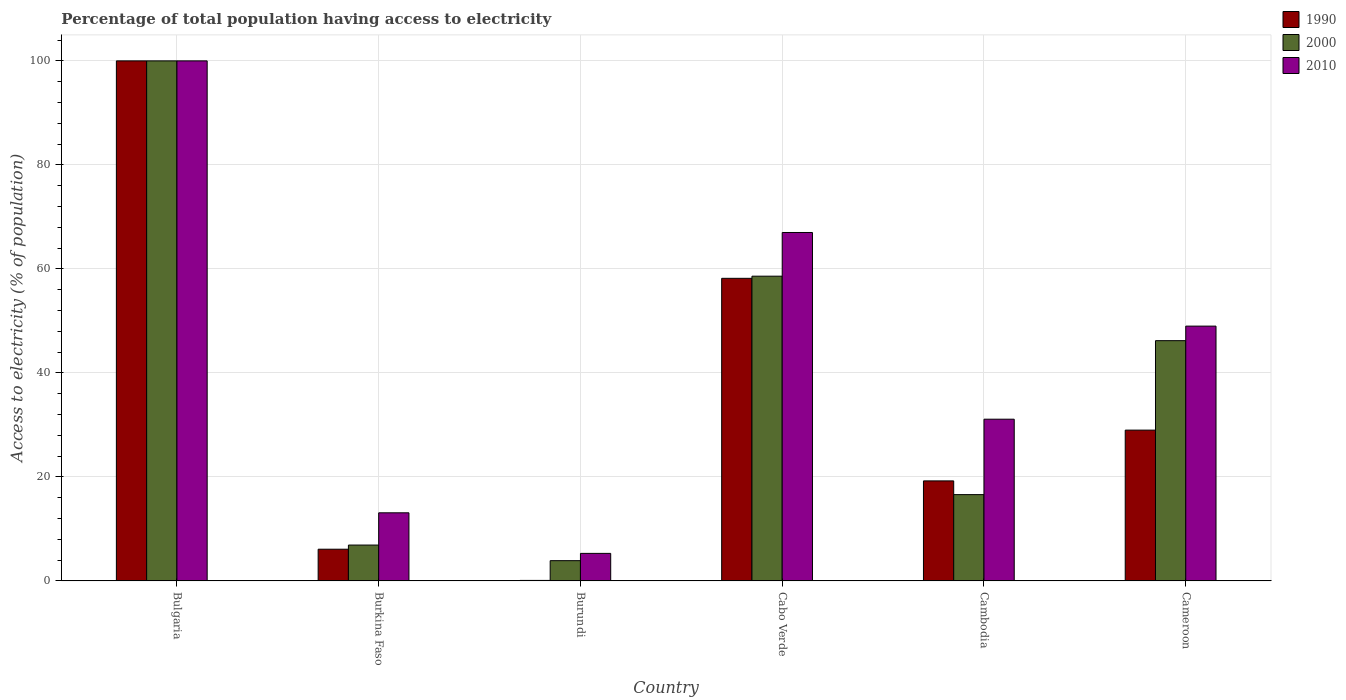How many groups of bars are there?
Offer a very short reply. 6. Are the number of bars on each tick of the X-axis equal?
Your response must be concise. Yes. What is the label of the 6th group of bars from the left?
Your answer should be compact. Cameroon. In which country was the percentage of population that have access to electricity in 2010 minimum?
Keep it short and to the point. Burundi. What is the total percentage of population that have access to electricity in 1990 in the graph?
Your answer should be very brief. 212.63. What is the difference between the percentage of population that have access to electricity in 1990 in Burundi and that in Cambodia?
Keep it short and to the point. -19.14. What is the difference between the percentage of population that have access to electricity in 2010 in Bulgaria and the percentage of population that have access to electricity in 2000 in Burkina Faso?
Ensure brevity in your answer.  93.1. What is the average percentage of population that have access to electricity in 1990 per country?
Provide a succinct answer. 35.44. In how many countries, is the percentage of population that have access to electricity in 1990 greater than 28 %?
Keep it short and to the point. 3. What is the ratio of the percentage of population that have access to electricity in 1990 in Burkina Faso to that in Burundi?
Ensure brevity in your answer.  61. What is the difference between the highest and the second highest percentage of population that have access to electricity in 2000?
Ensure brevity in your answer.  -41.4. What is the difference between the highest and the lowest percentage of population that have access to electricity in 2010?
Your answer should be very brief. 94.7. In how many countries, is the percentage of population that have access to electricity in 2010 greater than the average percentage of population that have access to electricity in 2010 taken over all countries?
Your answer should be very brief. 3. What does the 3rd bar from the left in Cameroon represents?
Make the answer very short. 2010. What does the 3rd bar from the right in Cambodia represents?
Your response must be concise. 1990. Is it the case that in every country, the sum of the percentage of population that have access to electricity in 1990 and percentage of population that have access to electricity in 2010 is greater than the percentage of population that have access to electricity in 2000?
Ensure brevity in your answer.  Yes. What is the difference between two consecutive major ticks on the Y-axis?
Make the answer very short. 20. Are the values on the major ticks of Y-axis written in scientific E-notation?
Provide a succinct answer. No. Does the graph contain grids?
Your response must be concise. Yes. Where does the legend appear in the graph?
Make the answer very short. Top right. How many legend labels are there?
Provide a short and direct response. 3. How are the legend labels stacked?
Ensure brevity in your answer.  Vertical. What is the title of the graph?
Your answer should be compact. Percentage of total population having access to electricity. Does "1962" appear as one of the legend labels in the graph?
Provide a short and direct response. No. What is the label or title of the Y-axis?
Your answer should be compact. Access to electricity (% of population). What is the Access to electricity (% of population) of 1990 in Bulgaria?
Ensure brevity in your answer.  100. What is the Access to electricity (% of population) of 2000 in Burkina Faso?
Provide a succinct answer. 6.9. What is the Access to electricity (% of population) of 2010 in Burkina Faso?
Provide a short and direct response. 13.1. What is the Access to electricity (% of population) of 1990 in Burundi?
Your response must be concise. 0.1. What is the Access to electricity (% of population) in 2000 in Burundi?
Your answer should be very brief. 3.9. What is the Access to electricity (% of population) in 1990 in Cabo Verde?
Offer a terse response. 58.19. What is the Access to electricity (% of population) in 2000 in Cabo Verde?
Offer a very short reply. 58.6. What is the Access to electricity (% of population) in 1990 in Cambodia?
Your answer should be very brief. 19.24. What is the Access to electricity (% of population) of 2000 in Cambodia?
Keep it short and to the point. 16.6. What is the Access to electricity (% of population) of 2010 in Cambodia?
Offer a terse response. 31.1. What is the Access to electricity (% of population) of 1990 in Cameroon?
Provide a succinct answer. 29. What is the Access to electricity (% of population) in 2000 in Cameroon?
Give a very brief answer. 46.2. What is the Access to electricity (% of population) in 2010 in Cameroon?
Keep it short and to the point. 49. Across all countries, what is the minimum Access to electricity (% of population) in 1990?
Your answer should be compact. 0.1. Across all countries, what is the minimum Access to electricity (% of population) in 2000?
Your answer should be very brief. 3.9. What is the total Access to electricity (% of population) of 1990 in the graph?
Ensure brevity in your answer.  212.63. What is the total Access to electricity (% of population) in 2000 in the graph?
Your answer should be compact. 232.2. What is the total Access to electricity (% of population) in 2010 in the graph?
Provide a short and direct response. 265.5. What is the difference between the Access to electricity (% of population) of 1990 in Bulgaria and that in Burkina Faso?
Offer a terse response. 93.9. What is the difference between the Access to electricity (% of population) of 2000 in Bulgaria and that in Burkina Faso?
Offer a very short reply. 93.1. What is the difference between the Access to electricity (% of population) in 2010 in Bulgaria and that in Burkina Faso?
Your answer should be compact. 86.9. What is the difference between the Access to electricity (% of population) of 1990 in Bulgaria and that in Burundi?
Offer a very short reply. 99.9. What is the difference between the Access to electricity (% of population) in 2000 in Bulgaria and that in Burundi?
Ensure brevity in your answer.  96.1. What is the difference between the Access to electricity (% of population) in 2010 in Bulgaria and that in Burundi?
Your answer should be compact. 94.7. What is the difference between the Access to electricity (% of population) in 1990 in Bulgaria and that in Cabo Verde?
Ensure brevity in your answer.  41.81. What is the difference between the Access to electricity (% of population) of 2000 in Bulgaria and that in Cabo Verde?
Your answer should be very brief. 41.4. What is the difference between the Access to electricity (% of population) in 1990 in Bulgaria and that in Cambodia?
Give a very brief answer. 80.76. What is the difference between the Access to electricity (% of population) in 2000 in Bulgaria and that in Cambodia?
Provide a short and direct response. 83.4. What is the difference between the Access to electricity (% of population) of 2010 in Bulgaria and that in Cambodia?
Your answer should be very brief. 68.9. What is the difference between the Access to electricity (% of population) of 2000 in Bulgaria and that in Cameroon?
Make the answer very short. 53.8. What is the difference between the Access to electricity (% of population) of 1990 in Burkina Faso and that in Burundi?
Your answer should be compact. 6. What is the difference between the Access to electricity (% of population) of 2000 in Burkina Faso and that in Burundi?
Offer a very short reply. 3. What is the difference between the Access to electricity (% of population) of 2010 in Burkina Faso and that in Burundi?
Your response must be concise. 7.8. What is the difference between the Access to electricity (% of population) of 1990 in Burkina Faso and that in Cabo Verde?
Your response must be concise. -52.09. What is the difference between the Access to electricity (% of population) in 2000 in Burkina Faso and that in Cabo Verde?
Your answer should be very brief. -51.7. What is the difference between the Access to electricity (% of population) in 2010 in Burkina Faso and that in Cabo Verde?
Offer a very short reply. -53.9. What is the difference between the Access to electricity (% of population) in 1990 in Burkina Faso and that in Cambodia?
Make the answer very short. -13.14. What is the difference between the Access to electricity (% of population) of 2010 in Burkina Faso and that in Cambodia?
Ensure brevity in your answer.  -18. What is the difference between the Access to electricity (% of population) of 1990 in Burkina Faso and that in Cameroon?
Provide a short and direct response. -22.9. What is the difference between the Access to electricity (% of population) of 2000 in Burkina Faso and that in Cameroon?
Offer a terse response. -39.3. What is the difference between the Access to electricity (% of population) of 2010 in Burkina Faso and that in Cameroon?
Provide a succinct answer. -35.9. What is the difference between the Access to electricity (% of population) in 1990 in Burundi and that in Cabo Verde?
Your answer should be very brief. -58.09. What is the difference between the Access to electricity (% of population) in 2000 in Burundi and that in Cabo Verde?
Give a very brief answer. -54.7. What is the difference between the Access to electricity (% of population) in 2010 in Burundi and that in Cabo Verde?
Offer a very short reply. -61.7. What is the difference between the Access to electricity (% of population) in 1990 in Burundi and that in Cambodia?
Your answer should be compact. -19.14. What is the difference between the Access to electricity (% of population) in 2000 in Burundi and that in Cambodia?
Provide a short and direct response. -12.7. What is the difference between the Access to electricity (% of population) of 2010 in Burundi and that in Cambodia?
Provide a succinct answer. -25.8. What is the difference between the Access to electricity (% of population) in 1990 in Burundi and that in Cameroon?
Your answer should be compact. -28.9. What is the difference between the Access to electricity (% of population) in 2000 in Burundi and that in Cameroon?
Provide a succinct answer. -42.3. What is the difference between the Access to electricity (% of population) in 2010 in Burundi and that in Cameroon?
Your answer should be compact. -43.7. What is the difference between the Access to electricity (% of population) of 1990 in Cabo Verde and that in Cambodia?
Offer a terse response. 38.95. What is the difference between the Access to electricity (% of population) of 2000 in Cabo Verde and that in Cambodia?
Give a very brief answer. 42. What is the difference between the Access to electricity (% of population) in 2010 in Cabo Verde and that in Cambodia?
Make the answer very short. 35.9. What is the difference between the Access to electricity (% of population) of 1990 in Cabo Verde and that in Cameroon?
Ensure brevity in your answer.  29.19. What is the difference between the Access to electricity (% of population) of 1990 in Cambodia and that in Cameroon?
Keep it short and to the point. -9.76. What is the difference between the Access to electricity (% of population) of 2000 in Cambodia and that in Cameroon?
Make the answer very short. -29.6. What is the difference between the Access to electricity (% of population) of 2010 in Cambodia and that in Cameroon?
Keep it short and to the point. -17.9. What is the difference between the Access to electricity (% of population) in 1990 in Bulgaria and the Access to electricity (% of population) in 2000 in Burkina Faso?
Keep it short and to the point. 93.1. What is the difference between the Access to electricity (% of population) of 1990 in Bulgaria and the Access to electricity (% of population) of 2010 in Burkina Faso?
Provide a short and direct response. 86.9. What is the difference between the Access to electricity (% of population) in 2000 in Bulgaria and the Access to electricity (% of population) in 2010 in Burkina Faso?
Give a very brief answer. 86.9. What is the difference between the Access to electricity (% of population) of 1990 in Bulgaria and the Access to electricity (% of population) of 2000 in Burundi?
Your answer should be very brief. 96.1. What is the difference between the Access to electricity (% of population) in 1990 in Bulgaria and the Access to electricity (% of population) in 2010 in Burundi?
Your response must be concise. 94.7. What is the difference between the Access to electricity (% of population) in 2000 in Bulgaria and the Access to electricity (% of population) in 2010 in Burundi?
Offer a terse response. 94.7. What is the difference between the Access to electricity (% of population) of 1990 in Bulgaria and the Access to electricity (% of population) of 2000 in Cabo Verde?
Offer a very short reply. 41.4. What is the difference between the Access to electricity (% of population) in 1990 in Bulgaria and the Access to electricity (% of population) in 2000 in Cambodia?
Provide a short and direct response. 83.4. What is the difference between the Access to electricity (% of population) of 1990 in Bulgaria and the Access to electricity (% of population) of 2010 in Cambodia?
Offer a terse response. 68.9. What is the difference between the Access to electricity (% of population) of 2000 in Bulgaria and the Access to electricity (% of population) of 2010 in Cambodia?
Keep it short and to the point. 68.9. What is the difference between the Access to electricity (% of population) of 1990 in Bulgaria and the Access to electricity (% of population) of 2000 in Cameroon?
Keep it short and to the point. 53.8. What is the difference between the Access to electricity (% of population) in 1990 in Bulgaria and the Access to electricity (% of population) in 2010 in Cameroon?
Give a very brief answer. 51. What is the difference between the Access to electricity (% of population) of 1990 in Burkina Faso and the Access to electricity (% of population) of 2000 in Burundi?
Offer a terse response. 2.2. What is the difference between the Access to electricity (% of population) in 1990 in Burkina Faso and the Access to electricity (% of population) in 2000 in Cabo Verde?
Your response must be concise. -52.5. What is the difference between the Access to electricity (% of population) of 1990 in Burkina Faso and the Access to electricity (% of population) of 2010 in Cabo Verde?
Your answer should be very brief. -60.9. What is the difference between the Access to electricity (% of population) of 2000 in Burkina Faso and the Access to electricity (% of population) of 2010 in Cabo Verde?
Offer a terse response. -60.1. What is the difference between the Access to electricity (% of population) of 1990 in Burkina Faso and the Access to electricity (% of population) of 2000 in Cambodia?
Ensure brevity in your answer.  -10.5. What is the difference between the Access to electricity (% of population) in 1990 in Burkina Faso and the Access to electricity (% of population) in 2010 in Cambodia?
Keep it short and to the point. -25. What is the difference between the Access to electricity (% of population) in 2000 in Burkina Faso and the Access to electricity (% of population) in 2010 in Cambodia?
Keep it short and to the point. -24.2. What is the difference between the Access to electricity (% of population) in 1990 in Burkina Faso and the Access to electricity (% of population) in 2000 in Cameroon?
Offer a very short reply. -40.1. What is the difference between the Access to electricity (% of population) in 1990 in Burkina Faso and the Access to electricity (% of population) in 2010 in Cameroon?
Your answer should be very brief. -42.9. What is the difference between the Access to electricity (% of population) in 2000 in Burkina Faso and the Access to electricity (% of population) in 2010 in Cameroon?
Make the answer very short. -42.1. What is the difference between the Access to electricity (% of population) of 1990 in Burundi and the Access to electricity (% of population) of 2000 in Cabo Verde?
Your response must be concise. -58.5. What is the difference between the Access to electricity (% of population) of 1990 in Burundi and the Access to electricity (% of population) of 2010 in Cabo Verde?
Offer a very short reply. -66.9. What is the difference between the Access to electricity (% of population) of 2000 in Burundi and the Access to electricity (% of population) of 2010 in Cabo Verde?
Ensure brevity in your answer.  -63.1. What is the difference between the Access to electricity (% of population) in 1990 in Burundi and the Access to electricity (% of population) in 2000 in Cambodia?
Your response must be concise. -16.5. What is the difference between the Access to electricity (% of population) of 1990 in Burundi and the Access to electricity (% of population) of 2010 in Cambodia?
Offer a terse response. -31. What is the difference between the Access to electricity (% of population) of 2000 in Burundi and the Access to electricity (% of population) of 2010 in Cambodia?
Offer a very short reply. -27.2. What is the difference between the Access to electricity (% of population) in 1990 in Burundi and the Access to electricity (% of population) in 2000 in Cameroon?
Your answer should be compact. -46.1. What is the difference between the Access to electricity (% of population) in 1990 in Burundi and the Access to electricity (% of population) in 2010 in Cameroon?
Your answer should be compact. -48.9. What is the difference between the Access to electricity (% of population) of 2000 in Burundi and the Access to electricity (% of population) of 2010 in Cameroon?
Keep it short and to the point. -45.1. What is the difference between the Access to electricity (% of population) of 1990 in Cabo Verde and the Access to electricity (% of population) of 2000 in Cambodia?
Your answer should be very brief. 41.59. What is the difference between the Access to electricity (% of population) in 1990 in Cabo Verde and the Access to electricity (% of population) in 2010 in Cambodia?
Make the answer very short. 27.09. What is the difference between the Access to electricity (% of population) of 2000 in Cabo Verde and the Access to electricity (% of population) of 2010 in Cambodia?
Offer a very short reply. 27.5. What is the difference between the Access to electricity (% of population) in 1990 in Cabo Verde and the Access to electricity (% of population) in 2000 in Cameroon?
Your answer should be very brief. 11.99. What is the difference between the Access to electricity (% of population) of 1990 in Cabo Verde and the Access to electricity (% of population) of 2010 in Cameroon?
Your answer should be compact. 9.19. What is the difference between the Access to electricity (% of population) in 1990 in Cambodia and the Access to electricity (% of population) in 2000 in Cameroon?
Your answer should be very brief. -26.96. What is the difference between the Access to electricity (% of population) of 1990 in Cambodia and the Access to electricity (% of population) of 2010 in Cameroon?
Give a very brief answer. -29.76. What is the difference between the Access to electricity (% of population) in 2000 in Cambodia and the Access to electricity (% of population) in 2010 in Cameroon?
Make the answer very short. -32.4. What is the average Access to electricity (% of population) in 1990 per country?
Your answer should be compact. 35.44. What is the average Access to electricity (% of population) in 2000 per country?
Ensure brevity in your answer.  38.7. What is the average Access to electricity (% of population) in 2010 per country?
Your answer should be very brief. 44.25. What is the difference between the Access to electricity (% of population) in 1990 and Access to electricity (% of population) in 2010 in Bulgaria?
Provide a succinct answer. 0. What is the difference between the Access to electricity (% of population) of 1990 and Access to electricity (% of population) of 2000 in Burundi?
Your answer should be very brief. -3.8. What is the difference between the Access to electricity (% of population) in 1990 and Access to electricity (% of population) in 2010 in Burundi?
Your answer should be compact. -5.2. What is the difference between the Access to electricity (% of population) of 1990 and Access to electricity (% of population) of 2000 in Cabo Verde?
Offer a terse response. -0.41. What is the difference between the Access to electricity (% of population) in 1990 and Access to electricity (% of population) in 2010 in Cabo Verde?
Offer a terse response. -8.81. What is the difference between the Access to electricity (% of population) in 2000 and Access to electricity (% of population) in 2010 in Cabo Verde?
Ensure brevity in your answer.  -8.4. What is the difference between the Access to electricity (% of population) of 1990 and Access to electricity (% of population) of 2000 in Cambodia?
Offer a terse response. 2.64. What is the difference between the Access to electricity (% of population) of 1990 and Access to electricity (% of population) of 2010 in Cambodia?
Your response must be concise. -11.86. What is the difference between the Access to electricity (% of population) in 1990 and Access to electricity (% of population) in 2000 in Cameroon?
Offer a terse response. -17.2. What is the ratio of the Access to electricity (% of population) of 1990 in Bulgaria to that in Burkina Faso?
Provide a short and direct response. 16.39. What is the ratio of the Access to electricity (% of population) of 2000 in Bulgaria to that in Burkina Faso?
Keep it short and to the point. 14.49. What is the ratio of the Access to electricity (% of population) of 2010 in Bulgaria to that in Burkina Faso?
Ensure brevity in your answer.  7.63. What is the ratio of the Access to electricity (% of population) of 2000 in Bulgaria to that in Burundi?
Offer a terse response. 25.64. What is the ratio of the Access to electricity (% of population) of 2010 in Bulgaria to that in Burundi?
Your answer should be very brief. 18.87. What is the ratio of the Access to electricity (% of population) of 1990 in Bulgaria to that in Cabo Verde?
Your answer should be compact. 1.72. What is the ratio of the Access to electricity (% of population) of 2000 in Bulgaria to that in Cabo Verde?
Give a very brief answer. 1.71. What is the ratio of the Access to electricity (% of population) in 2010 in Bulgaria to that in Cabo Verde?
Offer a very short reply. 1.49. What is the ratio of the Access to electricity (% of population) in 1990 in Bulgaria to that in Cambodia?
Give a very brief answer. 5.2. What is the ratio of the Access to electricity (% of population) in 2000 in Bulgaria to that in Cambodia?
Keep it short and to the point. 6.02. What is the ratio of the Access to electricity (% of population) of 2010 in Bulgaria to that in Cambodia?
Offer a very short reply. 3.22. What is the ratio of the Access to electricity (% of population) in 1990 in Bulgaria to that in Cameroon?
Your answer should be very brief. 3.45. What is the ratio of the Access to electricity (% of population) of 2000 in Bulgaria to that in Cameroon?
Offer a terse response. 2.16. What is the ratio of the Access to electricity (% of population) of 2010 in Bulgaria to that in Cameroon?
Offer a very short reply. 2.04. What is the ratio of the Access to electricity (% of population) of 1990 in Burkina Faso to that in Burundi?
Your response must be concise. 61. What is the ratio of the Access to electricity (% of population) of 2000 in Burkina Faso to that in Burundi?
Keep it short and to the point. 1.77. What is the ratio of the Access to electricity (% of population) in 2010 in Burkina Faso to that in Burundi?
Your answer should be compact. 2.47. What is the ratio of the Access to electricity (% of population) of 1990 in Burkina Faso to that in Cabo Verde?
Provide a succinct answer. 0.1. What is the ratio of the Access to electricity (% of population) in 2000 in Burkina Faso to that in Cabo Verde?
Make the answer very short. 0.12. What is the ratio of the Access to electricity (% of population) in 2010 in Burkina Faso to that in Cabo Verde?
Offer a terse response. 0.2. What is the ratio of the Access to electricity (% of population) in 1990 in Burkina Faso to that in Cambodia?
Offer a very short reply. 0.32. What is the ratio of the Access to electricity (% of population) in 2000 in Burkina Faso to that in Cambodia?
Give a very brief answer. 0.42. What is the ratio of the Access to electricity (% of population) in 2010 in Burkina Faso to that in Cambodia?
Give a very brief answer. 0.42. What is the ratio of the Access to electricity (% of population) of 1990 in Burkina Faso to that in Cameroon?
Make the answer very short. 0.21. What is the ratio of the Access to electricity (% of population) of 2000 in Burkina Faso to that in Cameroon?
Make the answer very short. 0.15. What is the ratio of the Access to electricity (% of population) in 2010 in Burkina Faso to that in Cameroon?
Make the answer very short. 0.27. What is the ratio of the Access to electricity (% of population) in 1990 in Burundi to that in Cabo Verde?
Ensure brevity in your answer.  0. What is the ratio of the Access to electricity (% of population) of 2000 in Burundi to that in Cabo Verde?
Offer a terse response. 0.07. What is the ratio of the Access to electricity (% of population) in 2010 in Burundi to that in Cabo Verde?
Offer a very short reply. 0.08. What is the ratio of the Access to electricity (% of population) in 1990 in Burundi to that in Cambodia?
Ensure brevity in your answer.  0.01. What is the ratio of the Access to electricity (% of population) of 2000 in Burundi to that in Cambodia?
Give a very brief answer. 0.23. What is the ratio of the Access to electricity (% of population) in 2010 in Burundi to that in Cambodia?
Your response must be concise. 0.17. What is the ratio of the Access to electricity (% of population) of 1990 in Burundi to that in Cameroon?
Ensure brevity in your answer.  0. What is the ratio of the Access to electricity (% of population) in 2000 in Burundi to that in Cameroon?
Give a very brief answer. 0.08. What is the ratio of the Access to electricity (% of population) in 2010 in Burundi to that in Cameroon?
Give a very brief answer. 0.11. What is the ratio of the Access to electricity (% of population) of 1990 in Cabo Verde to that in Cambodia?
Make the answer very short. 3.02. What is the ratio of the Access to electricity (% of population) in 2000 in Cabo Verde to that in Cambodia?
Offer a terse response. 3.53. What is the ratio of the Access to electricity (% of population) in 2010 in Cabo Verde to that in Cambodia?
Your response must be concise. 2.15. What is the ratio of the Access to electricity (% of population) in 1990 in Cabo Verde to that in Cameroon?
Offer a very short reply. 2.01. What is the ratio of the Access to electricity (% of population) in 2000 in Cabo Verde to that in Cameroon?
Provide a succinct answer. 1.27. What is the ratio of the Access to electricity (% of population) in 2010 in Cabo Verde to that in Cameroon?
Your answer should be very brief. 1.37. What is the ratio of the Access to electricity (% of population) in 1990 in Cambodia to that in Cameroon?
Give a very brief answer. 0.66. What is the ratio of the Access to electricity (% of population) in 2000 in Cambodia to that in Cameroon?
Your answer should be very brief. 0.36. What is the ratio of the Access to electricity (% of population) in 2010 in Cambodia to that in Cameroon?
Give a very brief answer. 0.63. What is the difference between the highest and the second highest Access to electricity (% of population) of 1990?
Give a very brief answer. 41.81. What is the difference between the highest and the second highest Access to electricity (% of population) of 2000?
Ensure brevity in your answer.  41.4. What is the difference between the highest and the lowest Access to electricity (% of population) in 1990?
Your answer should be compact. 99.9. What is the difference between the highest and the lowest Access to electricity (% of population) of 2000?
Your answer should be very brief. 96.1. What is the difference between the highest and the lowest Access to electricity (% of population) of 2010?
Your response must be concise. 94.7. 